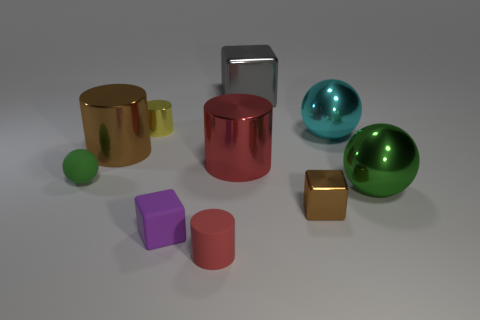How do the textures of the objects differ? There's a variety of textures in the scene. The cylinders and the sphere exhibit shiny, reflective surfaces. The green sphere, in particular, has a high gloss finish that reflects the environment, while the brown cylinder has a smoother, less reflective surface giving a satin-like appearance. The cubes are matte, with no significant reflection, which distinguishes them texturally from the cylinders and spheres. 